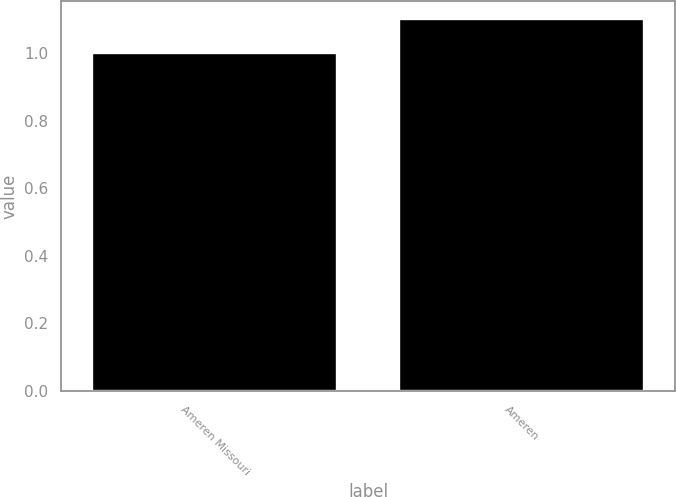Convert chart to OTSL. <chart><loc_0><loc_0><loc_500><loc_500><bar_chart><fcel>Ameren Missouri<fcel>Ameren<nl><fcel>1<fcel>1.1<nl></chart> 